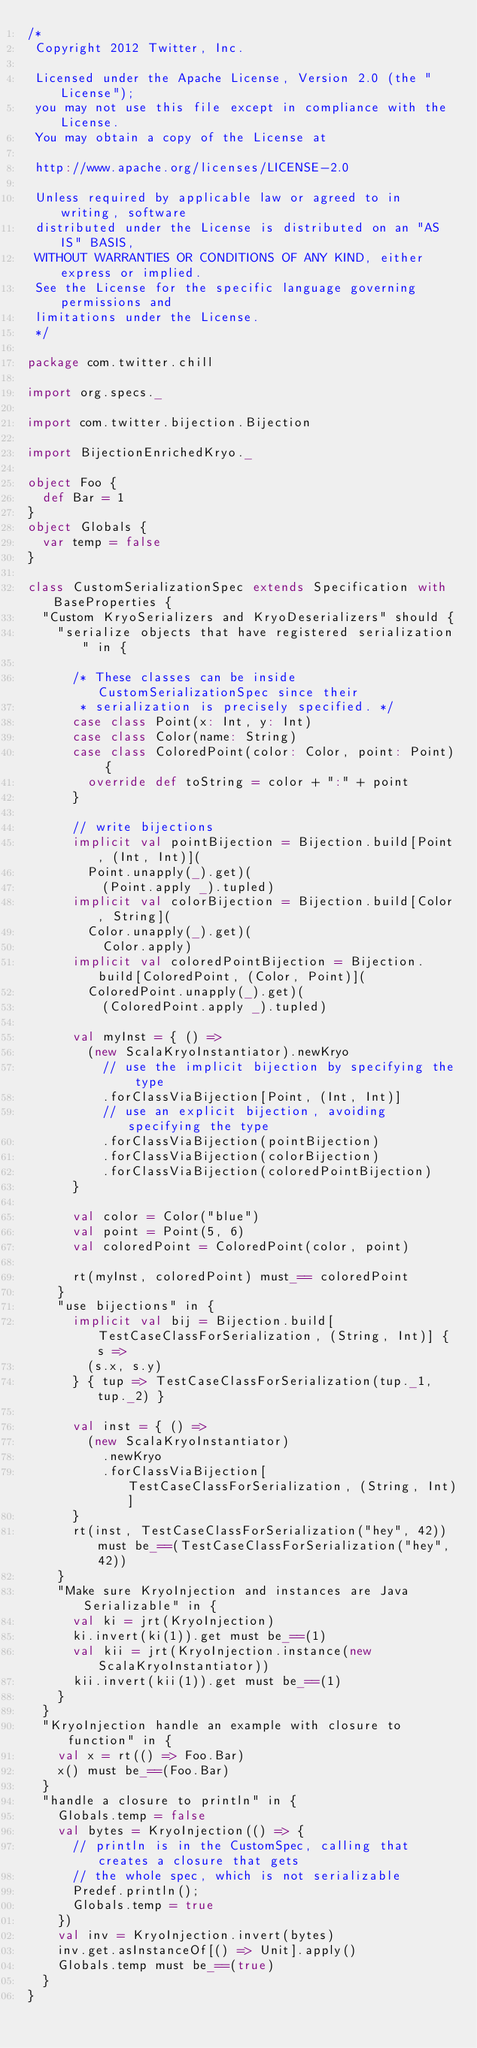Convert code to text. <code><loc_0><loc_0><loc_500><loc_500><_Scala_>/*
 Copyright 2012 Twitter, Inc.

 Licensed under the Apache License, Version 2.0 (the "License");
 you may not use this file except in compliance with the License.
 You may obtain a copy of the License at

 http://www.apache.org/licenses/LICENSE-2.0

 Unless required by applicable law or agreed to in writing, software
 distributed under the License is distributed on an "AS IS" BASIS,
 WITHOUT WARRANTIES OR CONDITIONS OF ANY KIND, either express or implied.
 See the License for the specific language governing permissions and
 limitations under the License.
 */

package com.twitter.chill

import org.specs._

import com.twitter.bijection.Bijection

import BijectionEnrichedKryo._

object Foo {
  def Bar = 1
}
object Globals {
  var temp = false
}

class CustomSerializationSpec extends Specification with BaseProperties {
  "Custom KryoSerializers and KryoDeserializers" should {
    "serialize objects that have registered serialization" in {

      /* These classes can be inside CustomSerializationSpec since their
       * serialization is precisely specified. */
      case class Point(x: Int, y: Int)
      case class Color(name: String)
      case class ColoredPoint(color: Color, point: Point) {
        override def toString = color + ":" + point
      }

      // write bijections
      implicit val pointBijection = Bijection.build[Point, (Int, Int)](
        Point.unapply(_).get)(
          (Point.apply _).tupled)
      implicit val colorBijection = Bijection.build[Color, String](
        Color.unapply(_).get)(
          Color.apply)
      implicit val coloredPointBijection = Bijection.build[ColoredPoint, (Color, Point)](
        ColoredPoint.unapply(_).get)(
          (ColoredPoint.apply _).tupled)

      val myInst = { () =>
        (new ScalaKryoInstantiator).newKryo
          // use the implicit bijection by specifying the type
          .forClassViaBijection[Point, (Int, Int)]
          // use an explicit bijection, avoiding specifying the type
          .forClassViaBijection(pointBijection)
          .forClassViaBijection(colorBijection)
          .forClassViaBijection(coloredPointBijection)
      }

      val color = Color("blue")
      val point = Point(5, 6)
      val coloredPoint = ColoredPoint(color, point)

      rt(myInst, coloredPoint) must_== coloredPoint
    }
    "use bijections" in {
      implicit val bij = Bijection.build[TestCaseClassForSerialization, (String, Int)] { s =>
        (s.x, s.y)
      } { tup => TestCaseClassForSerialization(tup._1, tup._2) }

      val inst = { () =>
        (new ScalaKryoInstantiator)
          .newKryo
          .forClassViaBijection[TestCaseClassForSerialization, (String, Int)]
      }
      rt(inst, TestCaseClassForSerialization("hey", 42)) must be_==(TestCaseClassForSerialization("hey", 42))
    }
    "Make sure KryoInjection and instances are Java Serializable" in {
      val ki = jrt(KryoInjection)
      ki.invert(ki(1)).get must be_==(1)
      val kii = jrt(KryoInjection.instance(new ScalaKryoInstantiator))
      kii.invert(kii(1)).get must be_==(1)
    }
  }
  "KryoInjection handle an example with closure to function" in {
    val x = rt(() => Foo.Bar)
    x() must be_==(Foo.Bar)
  }
  "handle a closure to println" in {
    Globals.temp = false
    val bytes = KryoInjection(() => {
      // println is in the CustomSpec, calling that creates a closure that gets
      // the whole spec, which is not serializable
      Predef.println();
      Globals.temp = true
    })
    val inv = KryoInjection.invert(bytes)
    inv.get.asInstanceOf[() => Unit].apply()
    Globals.temp must be_==(true)
  }
}
</code> 